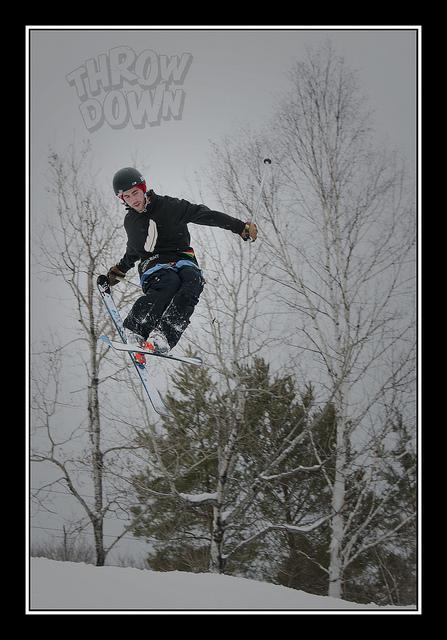How many vases glass vases are on the table?
Give a very brief answer. 0. 